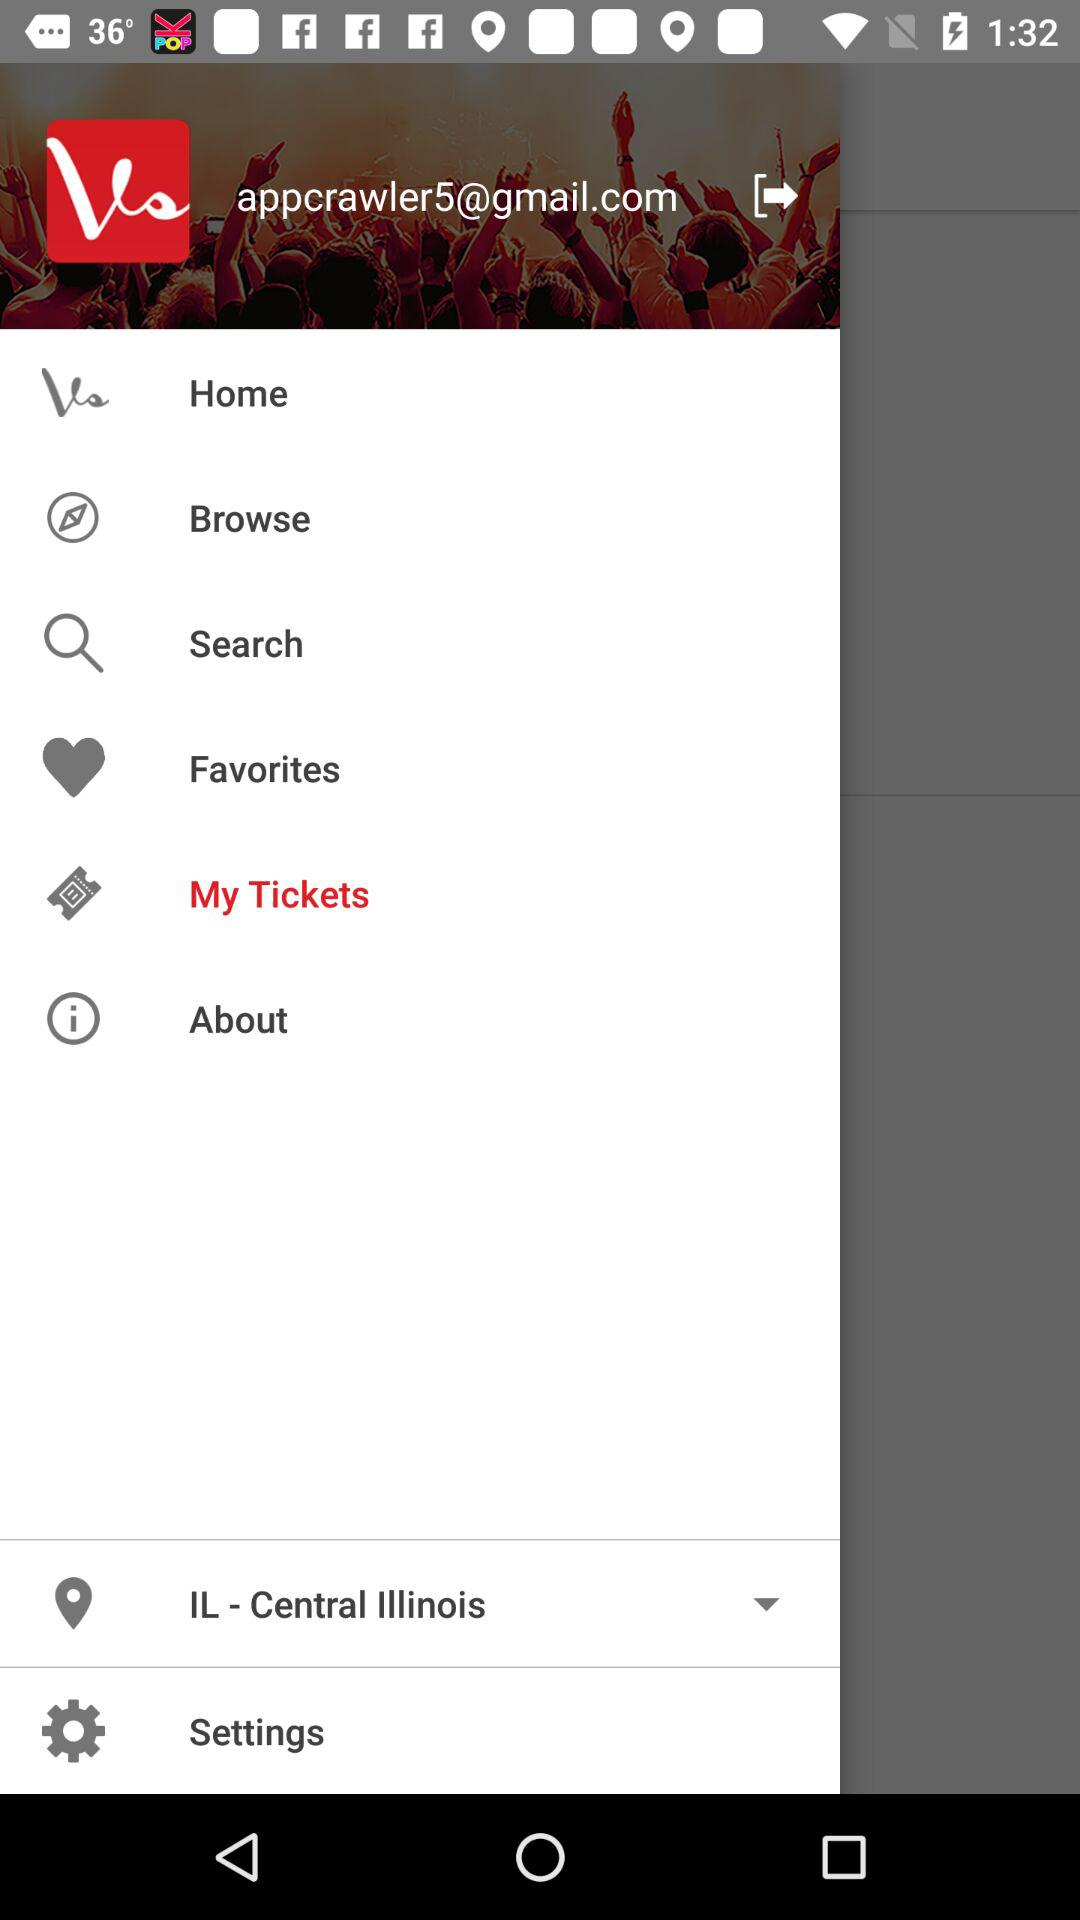What is the email address? The email address is appcrawler5@gmail.com. 